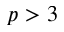<formula> <loc_0><loc_0><loc_500><loc_500>p > 3</formula> 